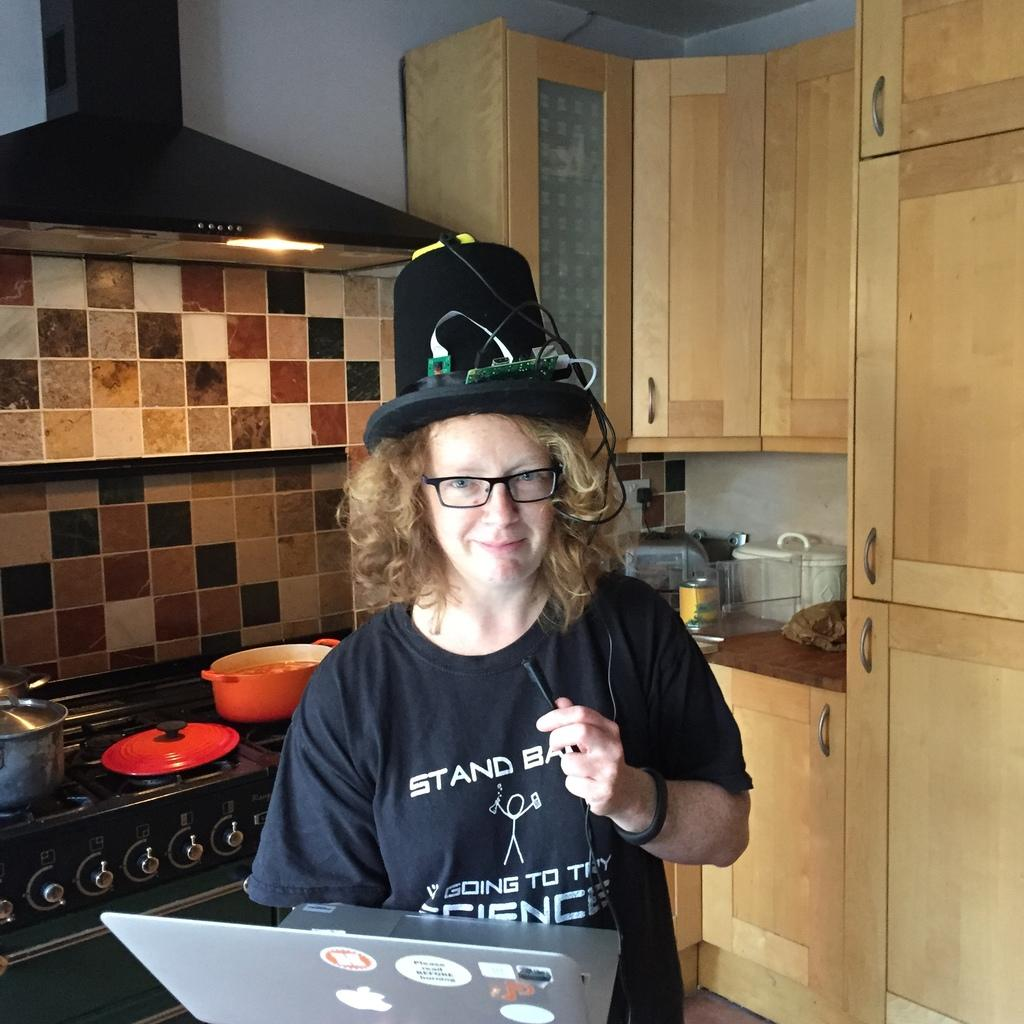What is the person in the image doing? The person is standing with a laptop in the image. What can be seen in the background of the image? In the background of the image, there is a chimney, tiles, a stove, vessels, objects, a cupboard, and a wall. Can you describe the setting of the image? The setting appears to be a kitchen or cooking area, as indicated by the presence of a stove, vessels, and cupboard. What type of brick is being used as bait in the image? There is no brick or bait present in the image. What is the person doing with their head in the image? The person's head is not shown doing anything in the image; they are simply standing with a laptop. 